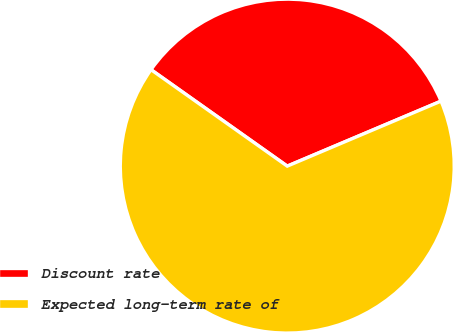Convert chart. <chart><loc_0><loc_0><loc_500><loc_500><pie_chart><fcel>Discount rate<fcel>Expected long-term rate of<nl><fcel>33.83%<fcel>66.17%<nl></chart> 